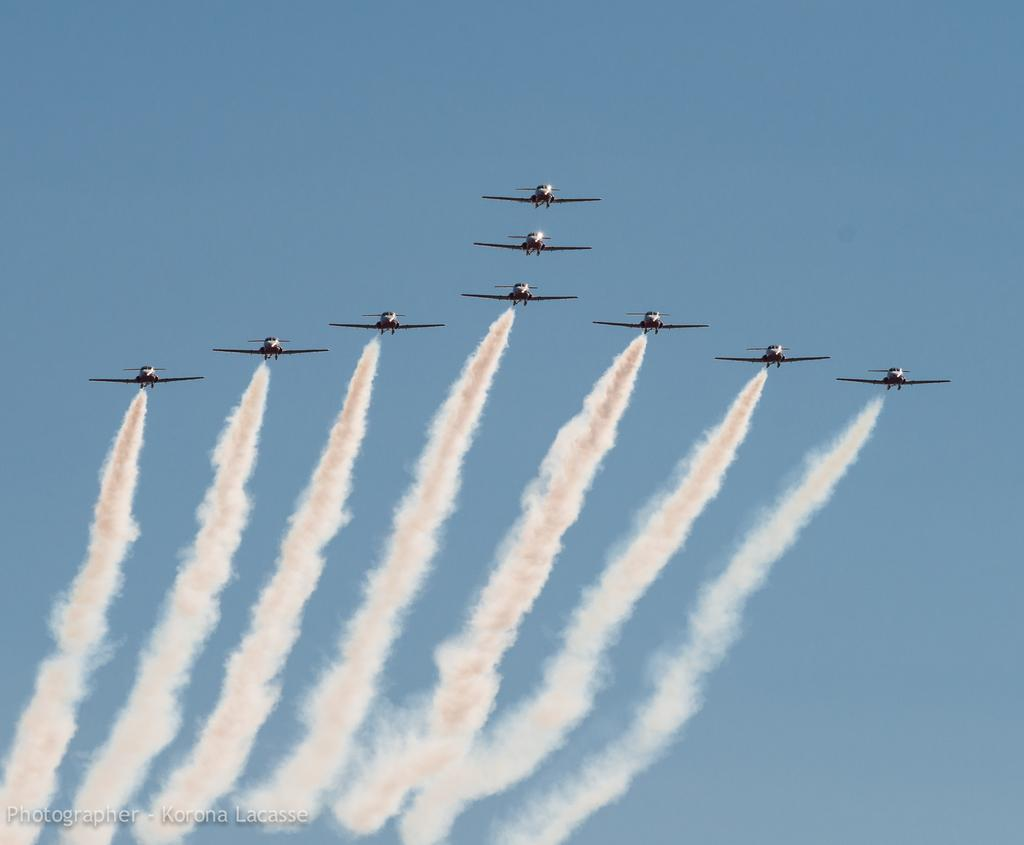What is the main subject of the image? The main subject of the image is aircrafts. What are the aircrafts doing in the image? The aircrafts are flying in the air. What can be seen behind the aircrafts in the image? There is smoke visible behind the aircrafts. What is visible in the background of the image? The sky is visible in the background of the image. How many ornaments are hanging from the aircrafts in the image? There are no ornaments present on the aircrafts in the image. What type of lizards can be seen crawling on the wings of the aircrafts in the image? There are no lizards present on the aircrafts in the image. 